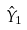Convert formula to latex. <formula><loc_0><loc_0><loc_500><loc_500>\hat { Y } _ { 1 }</formula> 